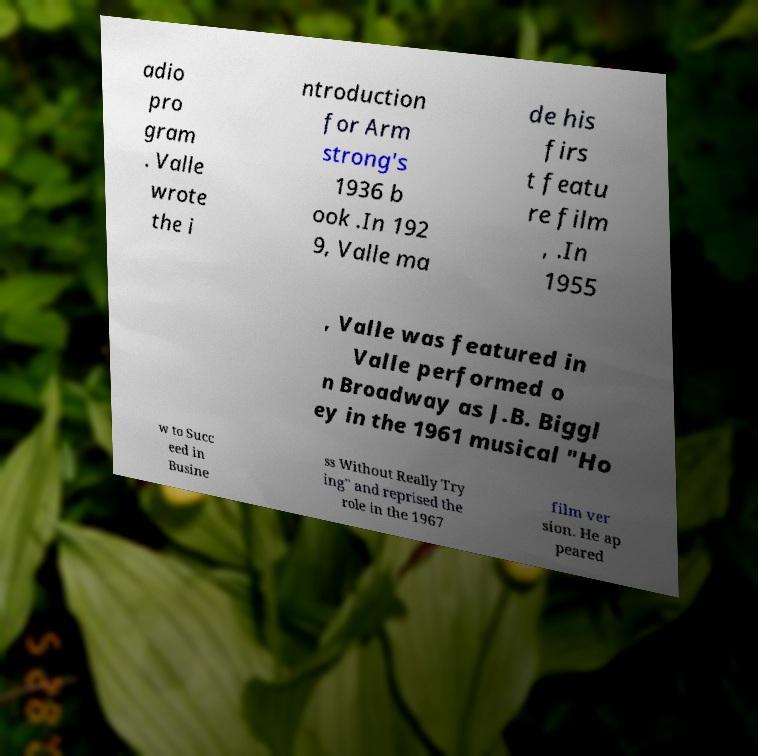I need the written content from this picture converted into text. Can you do that? adio pro gram . Valle wrote the i ntroduction for Arm strong's 1936 b ook .In 192 9, Valle ma de his firs t featu re film , .In 1955 , Valle was featured in Valle performed o n Broadway as J.B. Biggl ey in the 1961 musical "Ho w to Succ eed in Busine ss Without Really Try ing" and reprised the role in the 1967 film ver sion. He ap peared 